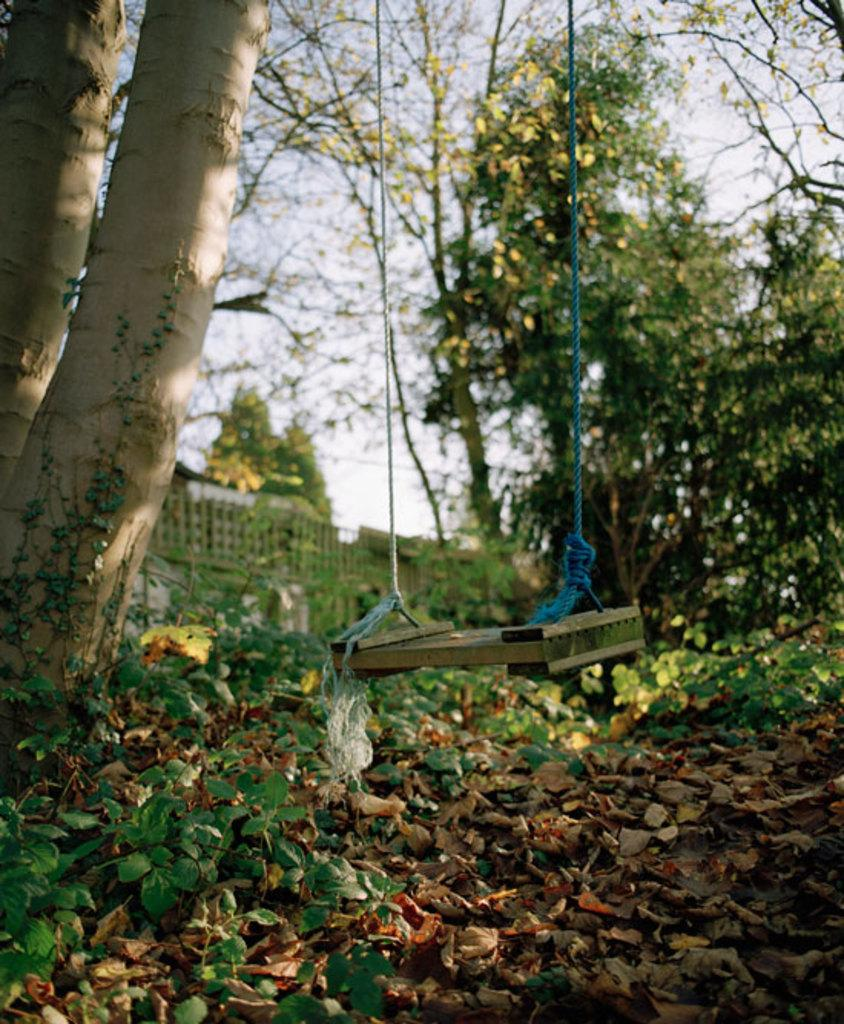What type of structure is visible in the image? There is a wooden swing with ropes in the image. What is on the ground in the image? Leaves and plants are on the ground in the image. What can be seen in the background of the image? There are trees and the sky visible in the background of the image. What type of barrier is present in the image? There is a fencing in the image. What type of vegetable is being served for dinner in the image? There is no dinner or vegetable present in the image; it features a wooden swing, leaves, plants, trees, the sky, and a fencing. 